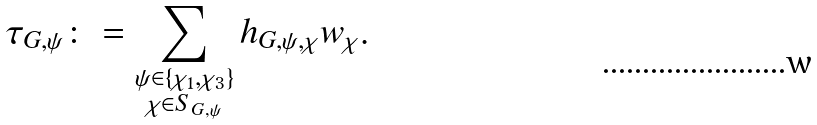Convert formula to latex. <formula><loc_0><loc_0><loc_500><loc_500>\tau _ { G , \psi } \colon = \sum _ { \substack { \psi \in \{ \chi _ { 1 } , \chi _ { 3 } \} \\ \chi \in S _ { G , \psi } } } h _ { G , \psi , \chi } w _ { \chi } .</formula> 